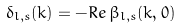Convert formula to latex. <formula><loc_0><loc_0><loc_500><loc_500>\delta _ { l , s } ( k ) = - R e \, \beta _ { l , s } ( k , 0 )</formula> 